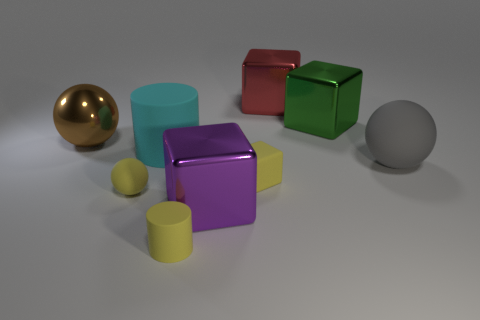What number of gray things are rubber objects or rubber cylinders?
Make the answer very short. 1. What number of things are red shiny things or small objects behind the purple block?
Give a very brief answer. 3. There is a big ball that is in front of the large brown ball; what is it made of?
Your response must be concise. Rubber. The rubber object that is the same size as the gray rubber sphere is what shape?
Give a very brief answer. Cylinder. Is there another large red object of the same shape as the large red thing?
Ensure brevity in your answer.  No. Is the red cube made of the same material as the large sphere to the right of the large brown metal ball?
Your answer should be very brief. No. What is the material of the block that is behind the big shiny thing that is right of the large red metal block?
Your response must be concise. Metal. Are there more cyan matte cylinders that are in front of the yellow cylinder than cyan objects?
Keep it short and to the point. No. Are any red matte cylinders visible?
Make the answer very short. No. There is a big matte object right of the yellow matte cylinder; what is its color?
Provide a short and direct response. Gray. 